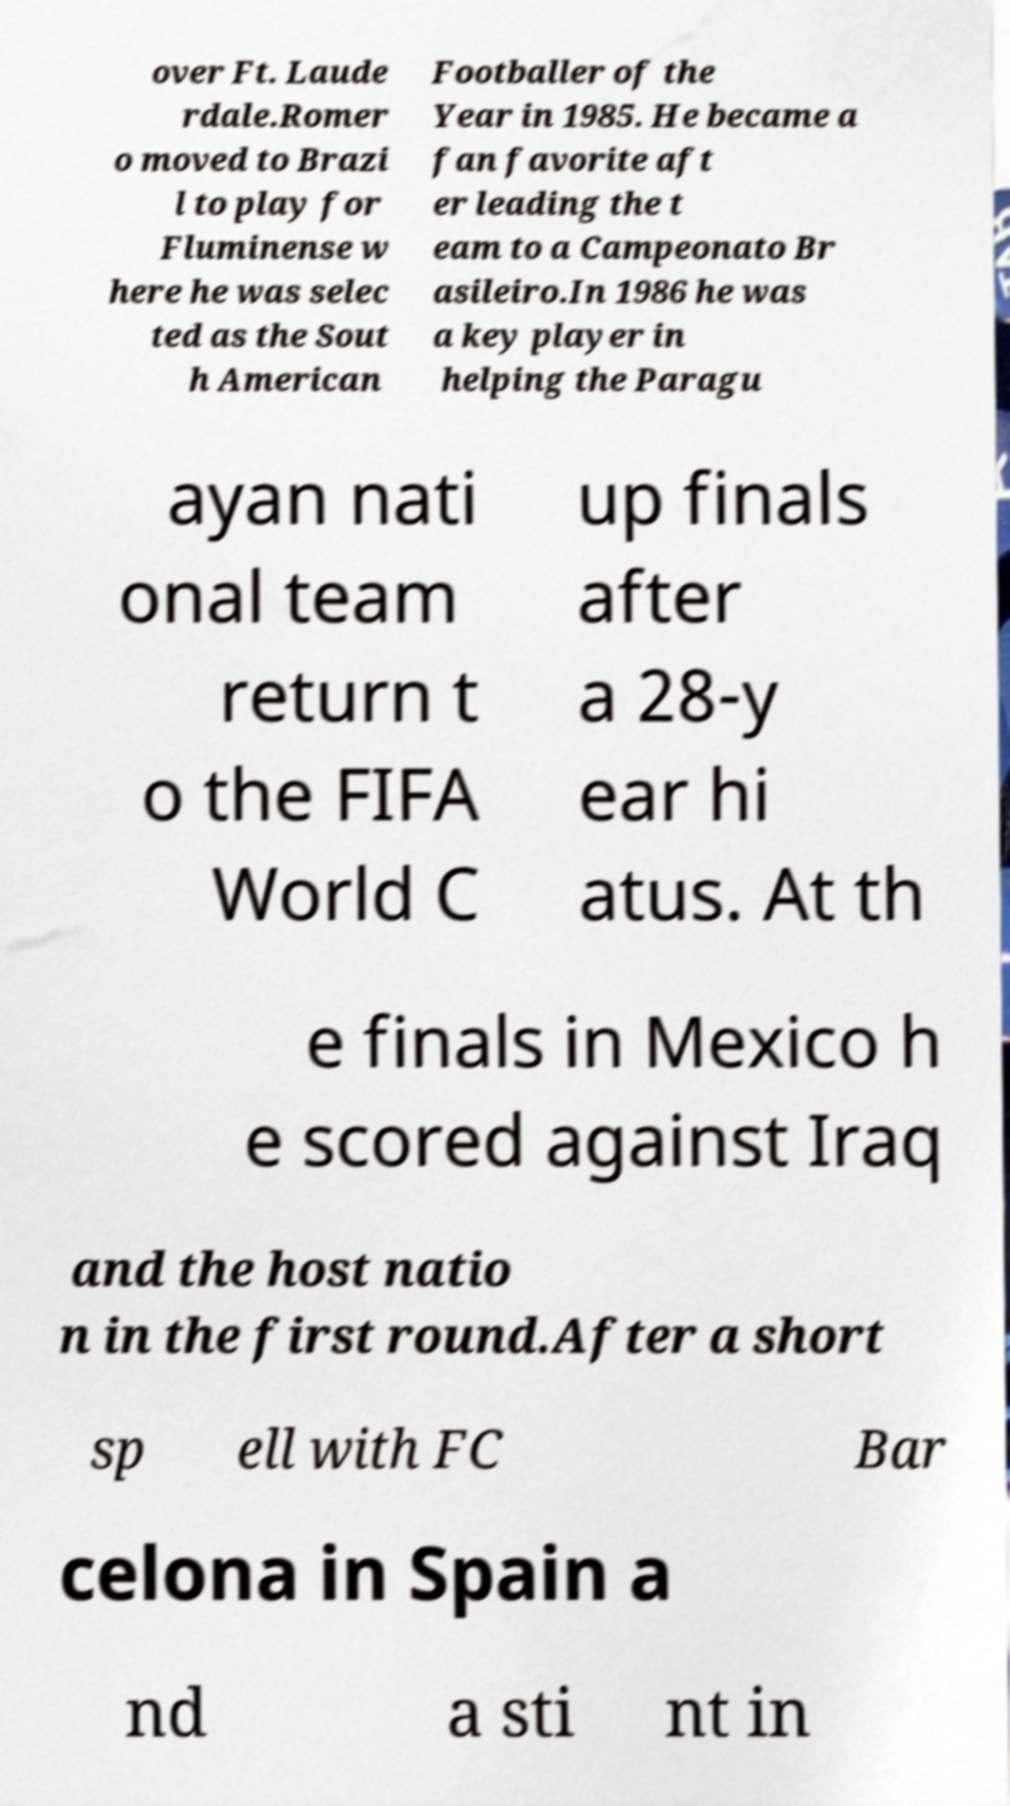For documentation purposes, I need the text within this image transcribed. Could you provide that? over Ft. Laude rdale.Romer o moved to Brazi l to play for Fluminense w here he was selec ted as the Sout h American Footballer of the Year in 1985. He became a fan favorite aft er leading the t eam to a Campeonato Br asileiro.In 1986 he was a key player in helping the Paragu ayan nati onal team return t o the FIFA World C up finals after a 28-y ear hi atus. At th e finals in Mexico h e scored against Iraq and the host natio n in the first round.After a short sp ell with FC Bar celona in Spain a nd a sti nt in 